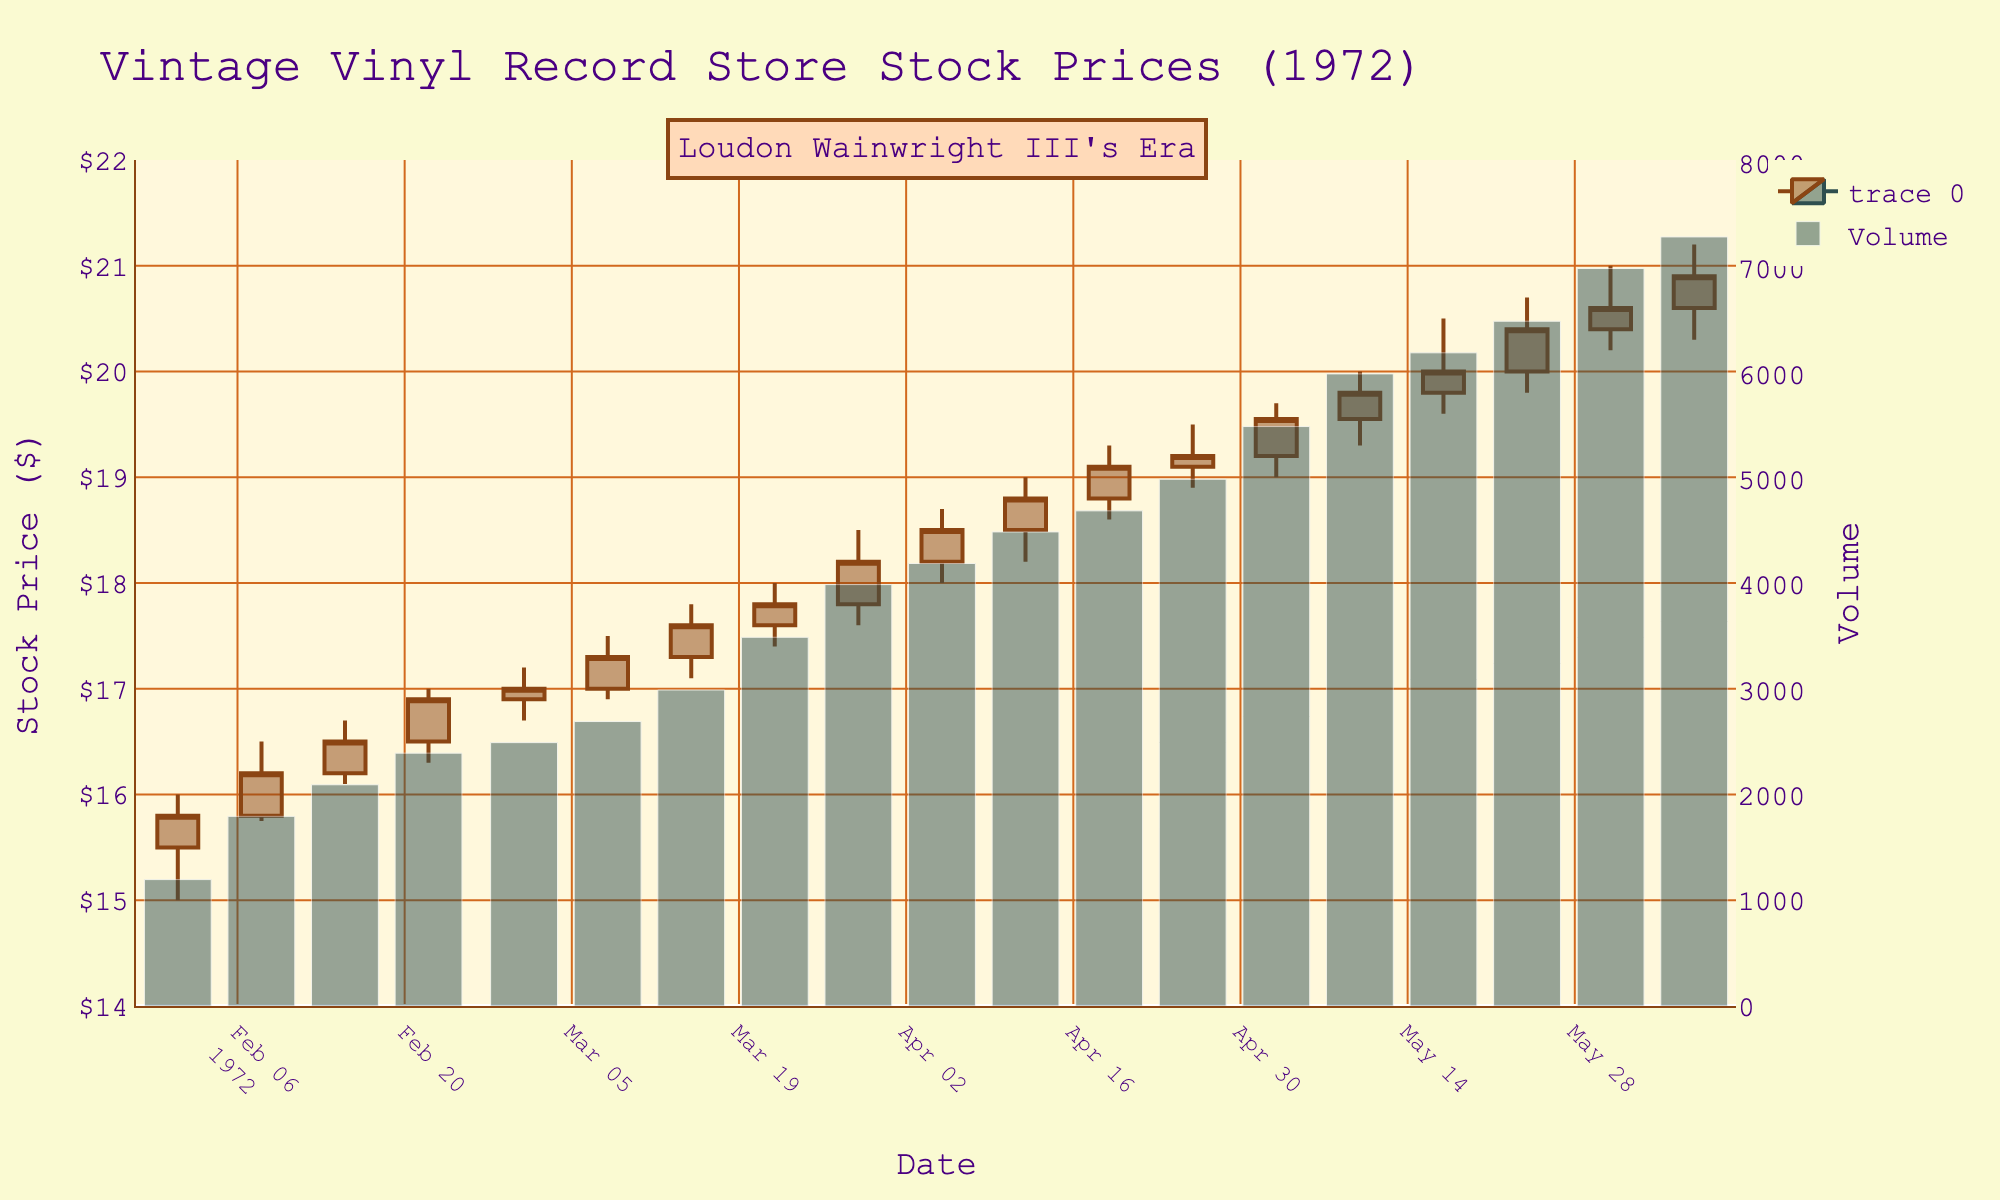What is the title of the plot? The title is usually located at the top of the plot and describes the content. In this figure, the title is "Vintage Vinyl Record Store Stock Prices (1972)" as per the code.
Answer: Vintage Vinyl Record Store Stock Prices (1972) Which date has the highest stock price? The highest stock price can be found by looking at the "High" values on the y-axis. The highest stock price in this data is on 1972-05-31 with a high of $21.00.
Answer: 1972-05-31 What does the color of the candlesticks indicate? The candlestick colors indicate whether the closing price was higher (SaddleBrown) or lower (DarkSlateGray) than the opening price. This distinction helps visualize stock movement trends.
Answer: Closing price higher or lower How did the stock price change from February 1 to June 7, 1972? By comparing the closing prices on February 1 ($15.80) and June 7 ($20.90), we see an increase. Calculation: $20.90 - $15.80 = $5.10.
Answer: Increased by $5.10 On which date was the trading volume the highest? Trading volume is indicated by the bar heights, combined with the data. The highest volume is on 1972-06-07 with 7,300 units traded.
Answer: 1972-06-07 What were the stock prices on the dates immediately after a major uptick? Major upticks can be observed on the candlestick chart. Following significant upticks (e.g., March 8), the stock price on March 15 opened at $17.30 and closed at $17.60.
Answer: Opened at $17.30, closed at $17.60 on March 15 What is the average closing price in March 1972? Add up the closing prices in March (17.00, 17.30, 17.60, 17.80) and divide by the number of weeks. Calculation: (17.00 + 17.30 + 17.60 + 17.80) / 4 = 17.43.
Answer: $17.43 How did the stock prices respond immediately after a significant announcement? Assuming a significant announcement on 1972-05-10, evaluate prices before and after. Before: $19.55 closing on 1972-05-03. After: $19.80 closing on 1972-05-10.
Answer: Increased from $19.55 to $19.80 Which periods show the most significant upward trends? Look for consistent increases in closing prices. March 8 to May 31 shows a consistent rise, initially from $17.00 to $20.60.
Answer: March 8 to May 31 How did the stock perform in the week of February 22, 1972? Check candlestick and bar for trading details on 1972-02-22. The stock price opened at $16.50, closed at $16.90 with a high of $17.00.
Answer: Opened at $16.50, closed at $16.90, high of $17.00 